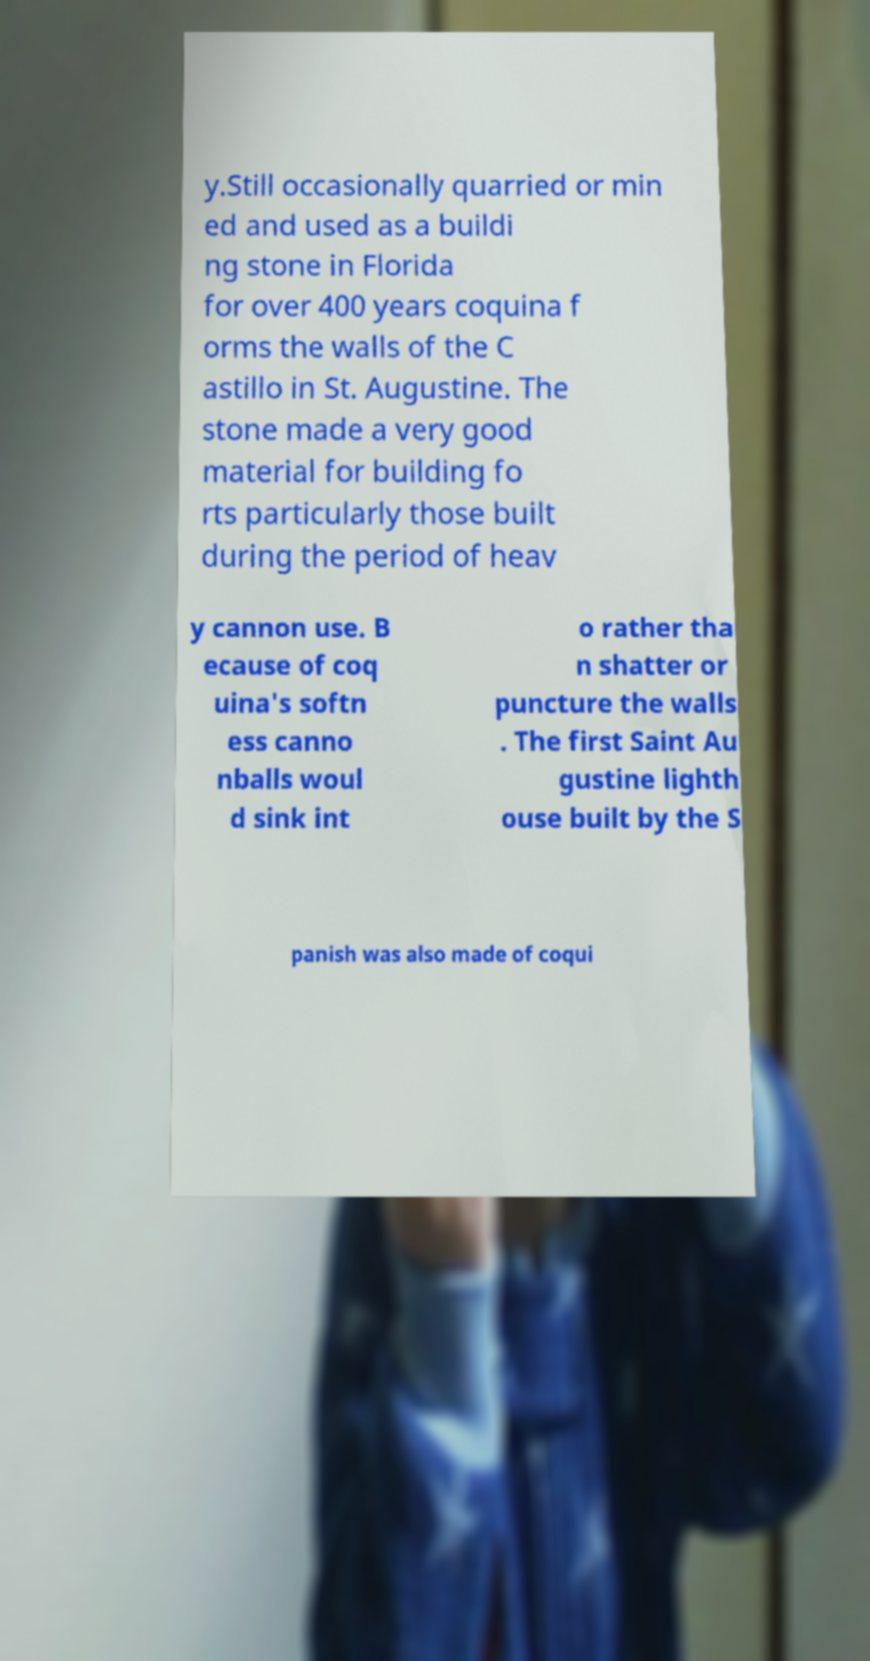Could you extract and type out the text from this image? y.Still occasionally quarried or min ed and used as a buildi ng stone in Florida for over 400 years coquina f orms the walls of the C astillo in St. Augustine. The stone made a very good material for building fo rts particularly those built during the period of heav y cannon use. B ecause of coq uina's softn ess canno nballs woul d sink int o rather tha n shatter or puncture the walls . The first Saint Au gustine lighth ouse built by the S panish was also made of coqui 